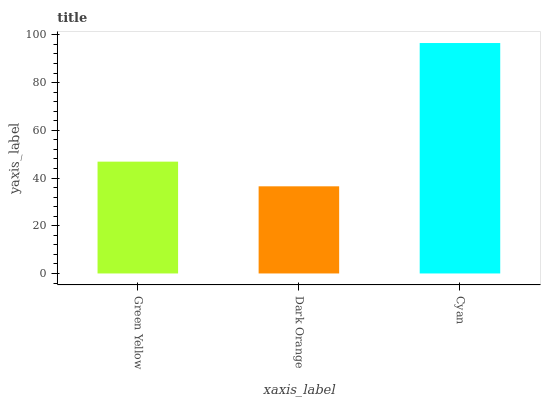Is Dark Orange the minimum?
Answer yes or no. Yes. Is Cyan the maximum?
Answer yes or no. Yes. Is Cyan the minimum?
Answer yes or no. No. Is Dark Orange the maximum?
Answer yes or no. No. Is Cyan greater than Dark Orange?
Answer yes or no. Yes. Is Dark Orange less than Cyan?
Answer yes or no. Yes. Is Dark Orange greater than Cyan?
Answer yes or no. No. Is Cyan less than Dark Orange?
Answer yes or no. No. Is Green Yellow the high median?
Answer yes or no. Yes. Is Green Yellow the low median?
Answer yes or no. Yes. Is Dark Orange the high median?
Answer yes or no. No. Is Cyan the low median?
Answer yes or no. No. 